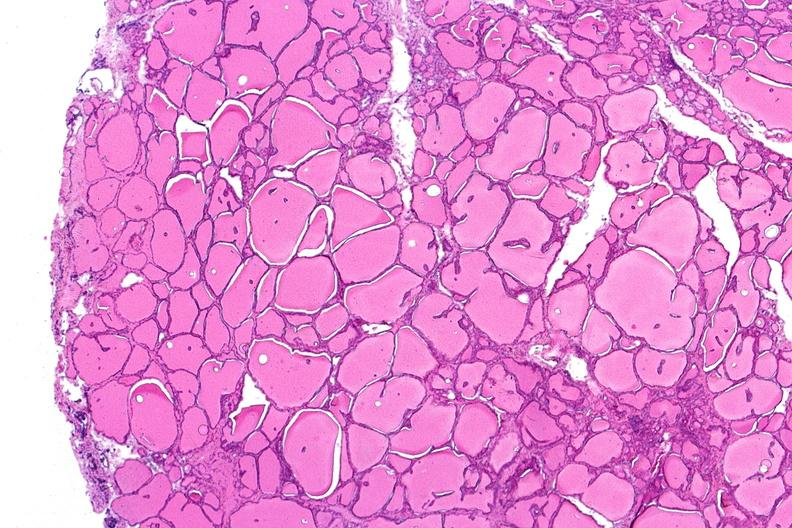where is this part in the figure?
Answer the question using a single word or phrase. Endocrine system 